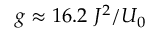Convert formula to latex. <formula><loc_0><loc_0><loc_500><loc_500>g \approx 1 6 . 2 \ J ^ { 2 } / U _ { 0 }</formula> 